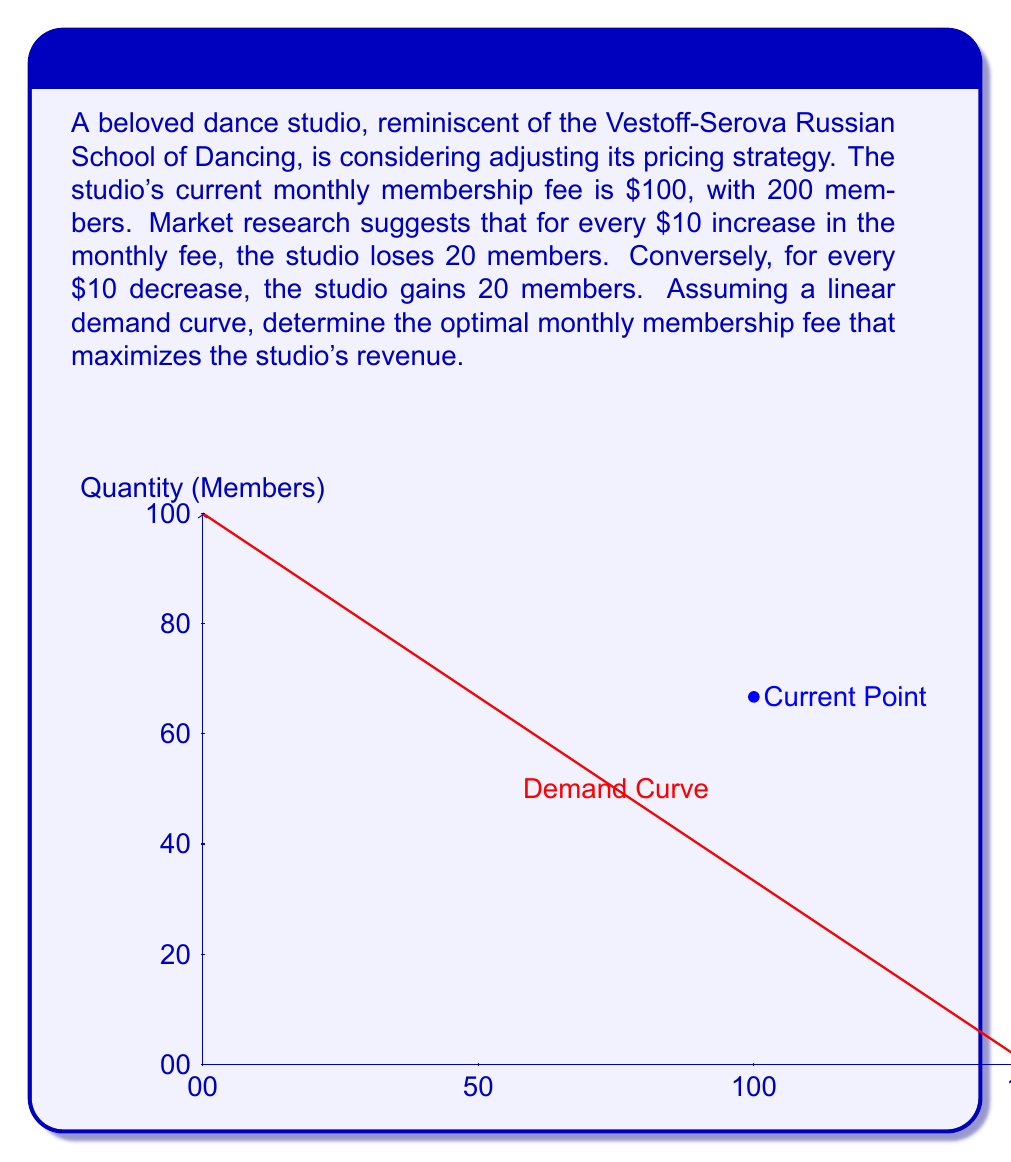Solve this math problem. Let's approach this step-by-step:

1) First, we need to determine the demand function. We know that:
   - At $100, there are 200 members
   - For every $10 change in price, there's a change of 20 members in the opposite direction

2) We can express this as a linear function: $Q = a - bP$
   Where $Q$ is quantity (number of members), $P$ is price, and $a$ and $b$ are constants.

3) Using the given information:
   $200 = a - 100b$ (current state)
   $180 = a - 110b$ (after $10 increase)

4) Subtracting these equations:
   $20 = 10b$
   $b = 2$

5) Substituting back:
   $200 = a - 100(2)$
   $a = 400$

6) So our demand function is: $Q = 400 - 2P$

7) Revenue (R) is price times quantity: $R = P * Q = P(400 - 2P) = 400P - 2P^2$

8) To maximize revenue, we find where the derivative of R with respect to P is zero:
   $\frac{dR}{dP} = 400 - 4P = 0$
   $400 = 4P$
   $P = 100$

9) The second derivative is negative ($-4$), confirming this is a maximum.

10) At $P = 100$, $Q = 400 - 2(100) = 200$

Therefore, the optimal price is $100, which is actually the current price.
Answer: $100 